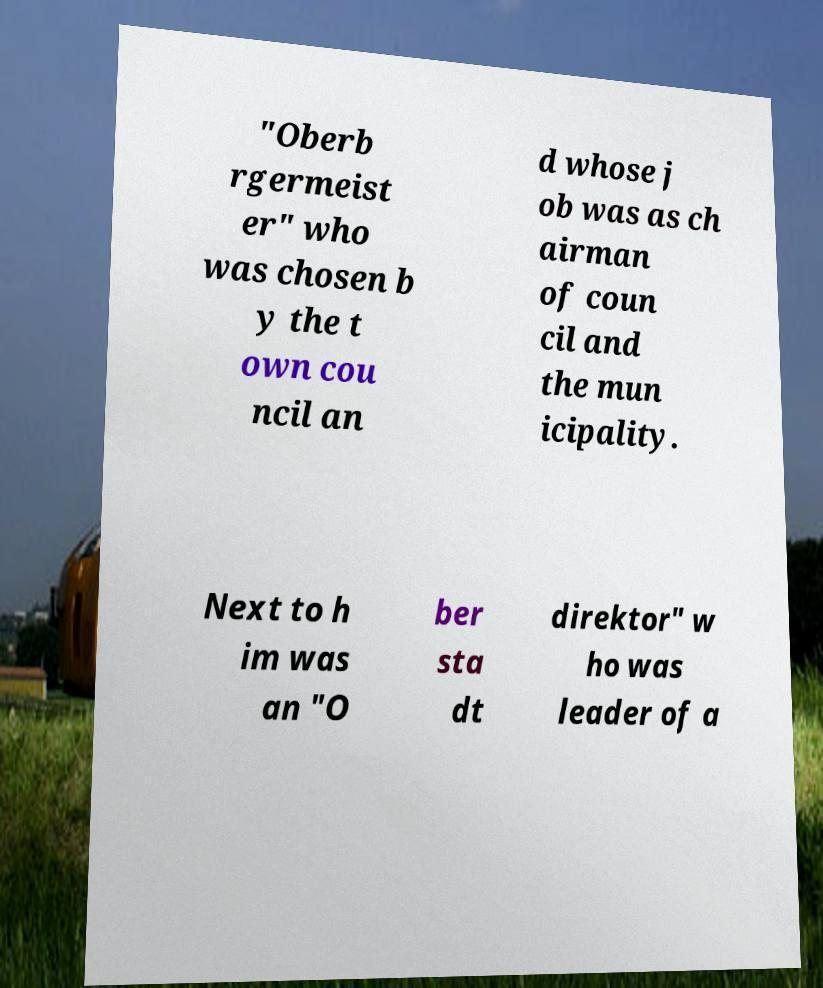Please identify and transcribe the text found in this image. "Oberb rgermeist er" who was chosen b y the t own cou ncil an d whose j ob was as ch airman of coun cil and the mun icipality. Next to h im was an "O ber sta dt direktor" w ho was leader of a 